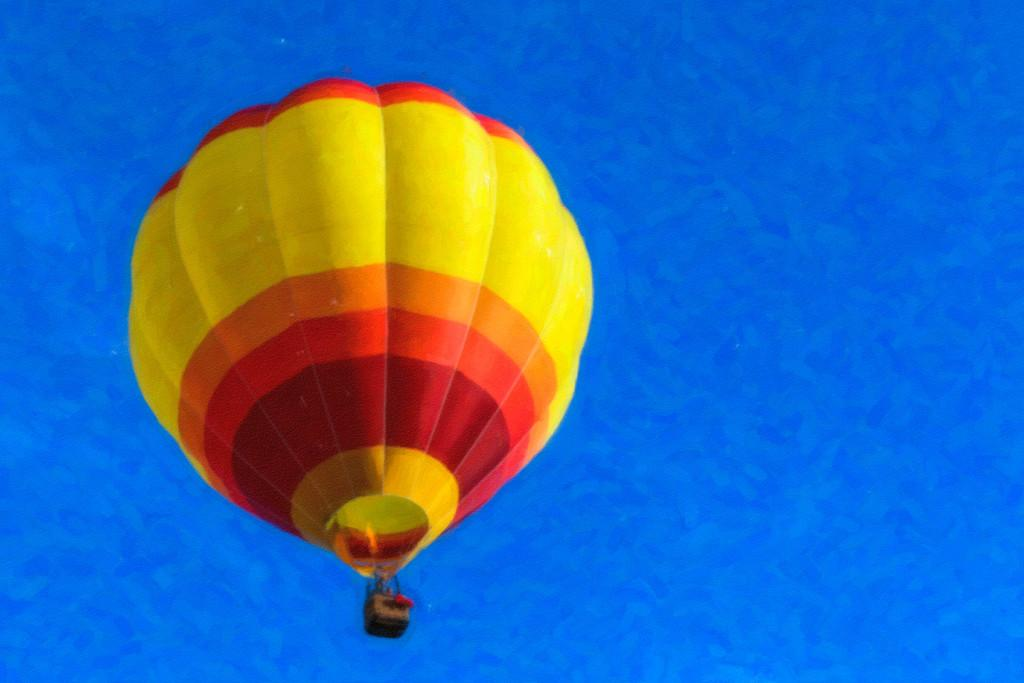What is the main object in the image? There is a parachute in the image. What colors can be seen on the parachute? The parachute has yellow, orange, and red colors. What color is the background of the image? The background of the image is blue. What type of instrument can be heard playing in the background of the image? There is no instrument or sound present in the image, as it only features a parachute and a blue background. 